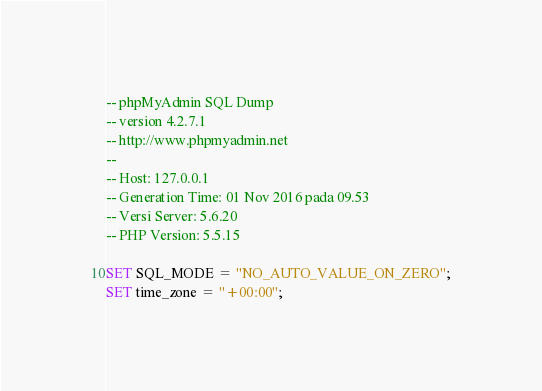<code> <loc_0><loc_0><loc_500><loc_500><_SQL_>-- phpMyAdmin SQL Dump
-- version 4.2.7.1
-- http://www.phpmyadmin.net
--
-- Host: 127.0.0.1
-- Generation Time: 01 Nov 2016 pada 09.53
-- Versi Server: 5.6.20
-- PHP Version: 5.5.15

SET SQL_MODE = "NO_AUTO_VALUE_ON_ZERO";
SET time_zone = "+00:00";

</code> 